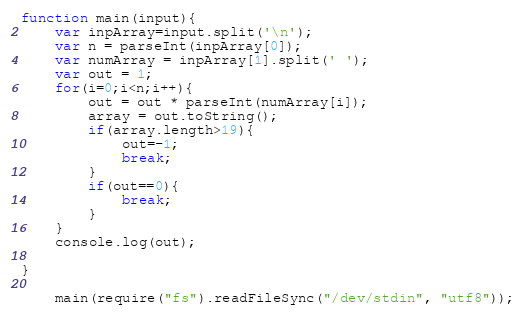<code> <loc_0><loc_0><loc_500><loc_500><_JavaScript_>function main(input){
    var inpArray=input.split('\n');
    var n = parseInt(inpArray[0]);
    var numArray = inpArray[1].split(' ');
    var out = 1;
    for(i=0;i<n;i++){
        out = out * parseInt(numArray[i]);
        array = out.toString();
        if(array.length>19){
            out=-1;
            break;
        }
        if(out==0){
            break;
        }
    }
    console.log(out);
     
}
     
    main(require("fs").readFileSync("/dev/stdin", "utf8"));</code> 